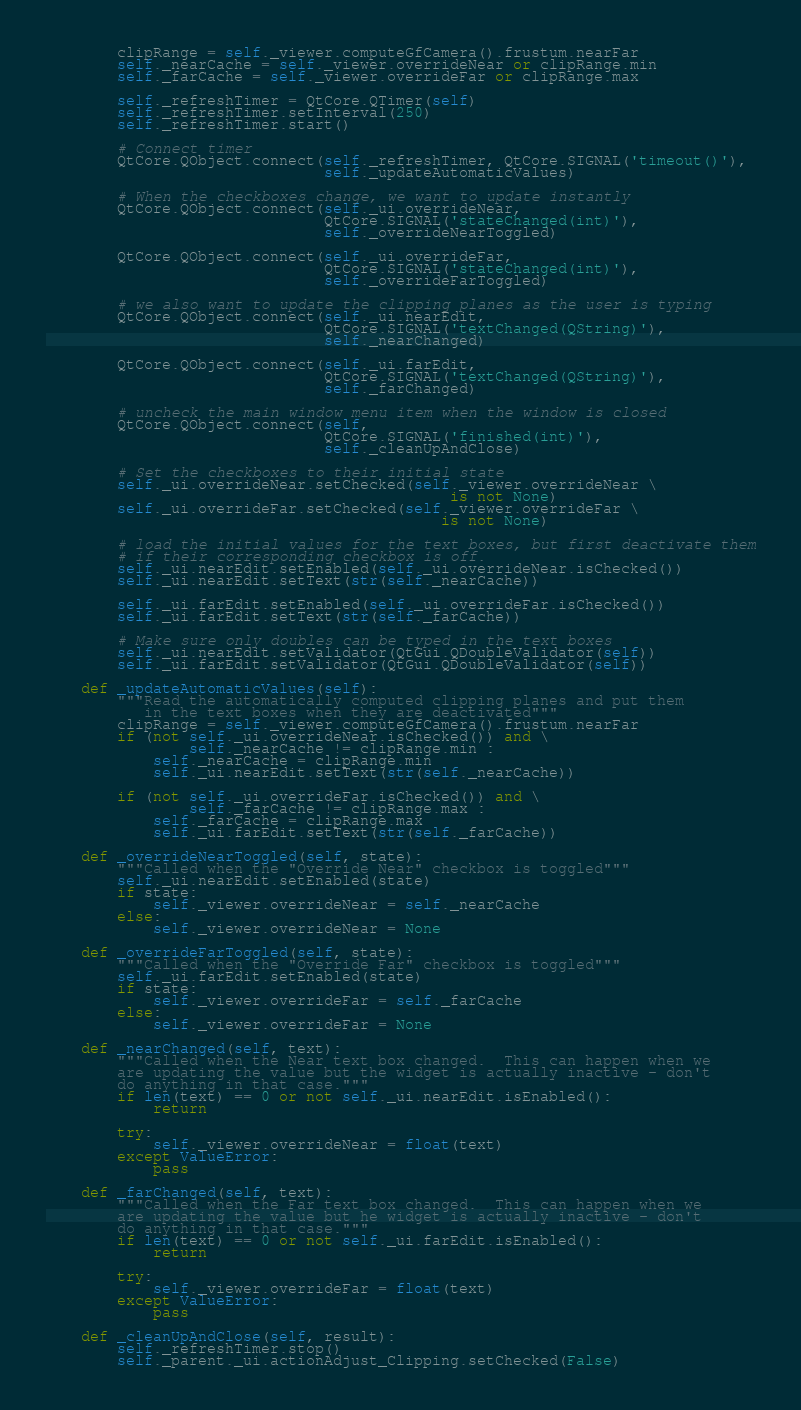Convert code to text. <code><loc_0><loc_0><loc_500><loc_500><_Python_>        clipRange = self._viewer.computeGfCamera().frustum.nearFar
        self._nearCache = self._viewer.overrideNear or clipRange.min
        self._farCache = self._viewer.overrideFar or clipRange.max

        self._refreshTimer = QtCore.QTimer(self)
        self._refreshTimer.setInterval(250)
        self._refreshTimer.start()

        # Connect timer
        QtCore.QObject.connect(self._refreshTimer, QtCore.SIGNAL('timeout()'),
                               self._updateAutomaticValues)

        # When the checkboxes change, we want to update instantly
        QtCore.QObject.connect(self._ui.overrideNear,
                               QtCore.SIGNAL('stateChanged(int)'),
                               self._overrideNearToggled)

        QtCore.QObject.connect(self._ui.overrideFar,
                               QtCore.SIGNAL('stateChanged(int)'),
                               self._overrideFarToggled)

        # we also want to update the clipping planes as the user is typing
        QtCore.QObject.connect(self._ui.nearEdit,
                               QtCore.SIGNAL('textChanged(QString)'),
                               self._nearChanged)

        QtCore.QObject.connect(self._ui.farEdit,
                               QtCore.SIGNAL('textChanged(QString)'),
                               self._farChanged)

        # uncheck the main window menu item when the window is closed
        QtCore.QObject.connect(self,
                               QtCore.SIGNAL('finished(int)'),
                               self._cleanUpAndClose)

        # Set the checkboxes to their initial state
        self._ui.overrideNear.setChecked(self._viewer.overrideNear \
                                             is not None)
        self._ui.overrideFar.setChecked(self._viewer.overrideFar \
                                            is not None)

        # load the initial values for the text boxes, but first deactivate them
        # if their corresponding checkbox is off.
        self._ui.nearEdit.setEnabled(self._ui.overrideNear.isChecked())
        self._ui.nearEdit.setText(str(self._nearCache))

        self._ui.farEdit.setEnabled(self._ui.overrideFar.isChecked())
        self._ui.farEdit.setText(str(self._farCache))

        # Make sure only doubles can be typed in the text boxes
        self._ui.nearEdit.setValidator(QtGui.QDoubleValidator(self))
        self._ui.farEdit.setValidator(QtGui.QDoubleValidator(self))

    def _updateAutomaticValues(self):
        """Read the automatically computed clipping planes and put them
           in the text boxes when they are deactivated"""
        clipRange = self._viewer.computeGfCamera().frustum.nearFar
        if (not self._ui.overrideNear.isChecked()) and \
                self._nearCache != clipRange.min :
            self._nearCache = clipRange.min
            self._ui.nearEdit.setText(str(self._nearCache))

        if (not self._ui.overrideFar.isChecked()) and \
                self._farCache != clipRange.max :
            self._farCache = clipRange.max
            self._ui.farEdit.setText(str(self._farCache))

    def _overrideNearToggled(self, state):
        """Called when the "Override Near" checkbox is toggled"""
        self._ui.nearEdit.setEnabled(state)
        if state:
            self._viewer.overrideNear = self._nearCache
        else:
            self._viewer.overrideNear = None

    def _overrideFarToggled(self, state):
        """Called when the "Override Far" checkbox is toggled"""
        self._ui.farEdit.setEnabled(state)
        if state:
            self._viewer.overrideFar = self._farCache
        else:
            self._viewer.overrideFar = None

    def _nearChanged(self, text):
        """Called when the Near text box changed.  This can happen when we
        are updating the value but the widget is actually inactive - don't
        do anything in that case."""
        if len(text) == 0 or not self._ui.nearEdit.isEnabled():
            return

        try:
            self._viewer.overrideNear = float(text)
        except ValueError:
            pass

    def _farChanged(self, text):
        """Called when the Far text box changed.  This can happen when we
        are updating the value but he widget is actually inactive - don't
        do anything in that case."""
        if len(text) == 0 or not self._ui.farEdit.isEnabled():
            return

        try:
            self._viewer.overrideFar = float(text)
        except ValueError:
            pass

    def _cleanUpAndClose(self, result):
        self._refreshTimer.stop()
        self._parent._ui.actionAdjust_Clipping.setChecked(False)
</code> 